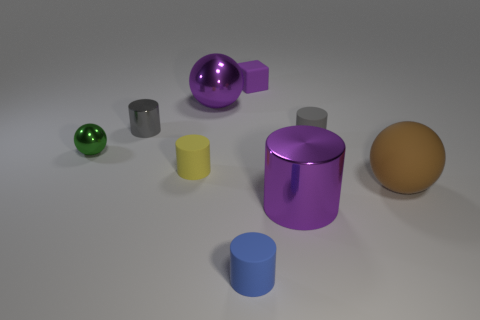Add 1 gray shiny cylinders. How many objects exist? 10 Subtract all matte cylinders. How many cylinders are left? 2 Subtract all yellow cylinders. How many cylinders are left? 4 Add 6 gray shiny cylinders. How many gray shiny cylinders are left? 7 Add 5 small yellow rubber cylinders. How many small yellow rubber cylinders exist? 6 Subtract 0 red balls. How many objects are left? 9 Subtract all cubes. How many objects are left? 8 Subtract 1 cubes. How many cubes are left? 0 Subtract all purple spheres. Subtract all green cubes. How many spheres are left? 2 Subtract all cyan spheres. How many red cubes are left? 0 